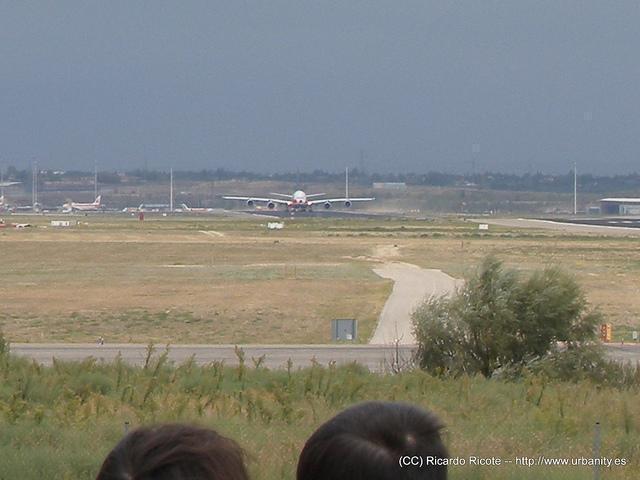Who gives the airplanes guidelines on where to take off and land?
Choose the correct response and explain in the format: 'Answer: answer
Rationale: rationale.'
Options: Spies, wardens, air control, pilots. Answer: wardens.
Rationale: The planes have wardens. 